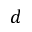Convert formula to latex. <formula><loc_0><loc_0><loc_500><loc_500>d</formula> 